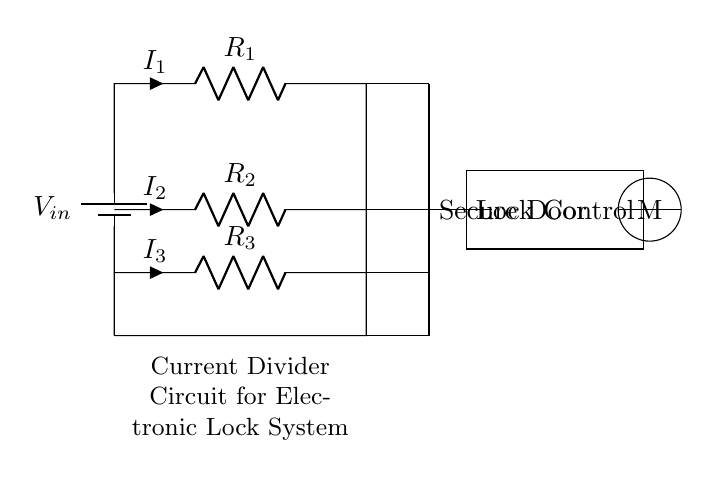What is the total number of resistors in this circuit? The circuit displays three resistors labeled as R1, R2, and R3, which can be counted visually.
Answer: 3 What component connects directly to the secure door? The lines from the circuit connect to a node labeled "Secure Door," indicating the connection.
Answer: Secure Door What is the current direction through R1? The current through R1 is indicated by the arrow labeled I1, showing that it flows from the top to the bottom of the resistor.
Answer: Downward Which resistor receives the least current? In a current divider circuit, the resistor with the highest resistance will receive the least current. Without specific values, visually comparing their sizes, R3 appears to be the highest resistor.
Answer: R3 What is the purpose of the lock control box in the circuit? The lock control box is positioned downstream of the current dividers and serves as a control mechanism based on the current delivered from the three resistors.
Answer: Lock Control What type of circuit is represented in this diagram? This is a current divider circuit because it divides the input current into parts that flow through each of the resistors connected in parallel.
Answer: Current Divider What does the letter M represent in the circuit? The letter M is inside a circle, implying it could represent a measuring device or a locking mechanism that activates based on the current supplied from the circuit.
Answer: M 